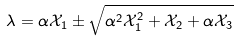<formula> <loc_0><loc_0><loc_500><loc_500>\lambda = \alpha \mathcal { X } _ { 1 } \pm \sqrt { \alpha ^ { 2 } \mathcal { X } _ { 1 } ^ { 2 } + \mathcal { X } _ { 2 } + \alpha \mathcal { X } _ { 3 } }</formula> 